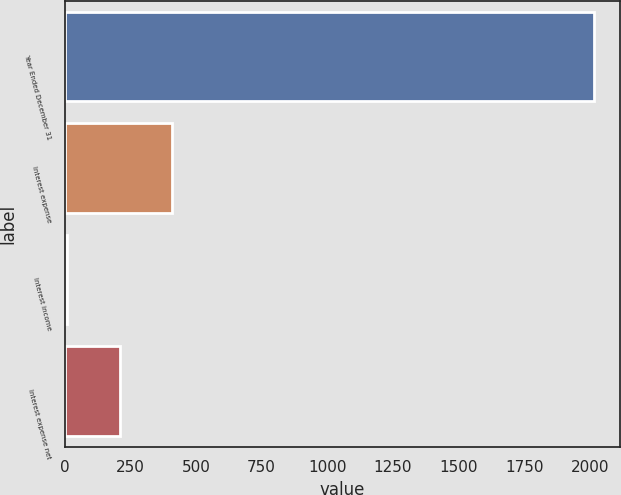<chart> <loc_0><loc_0><loc_500><loc_500><bar_chart><fcel>Year Ended December 31<fcel>Interest expense<fcel>Interest income<fcel>Interest expense net<nl><fcel>2016<fcel>409.6<fcel>8<fcel>208.8<nl></chart> 